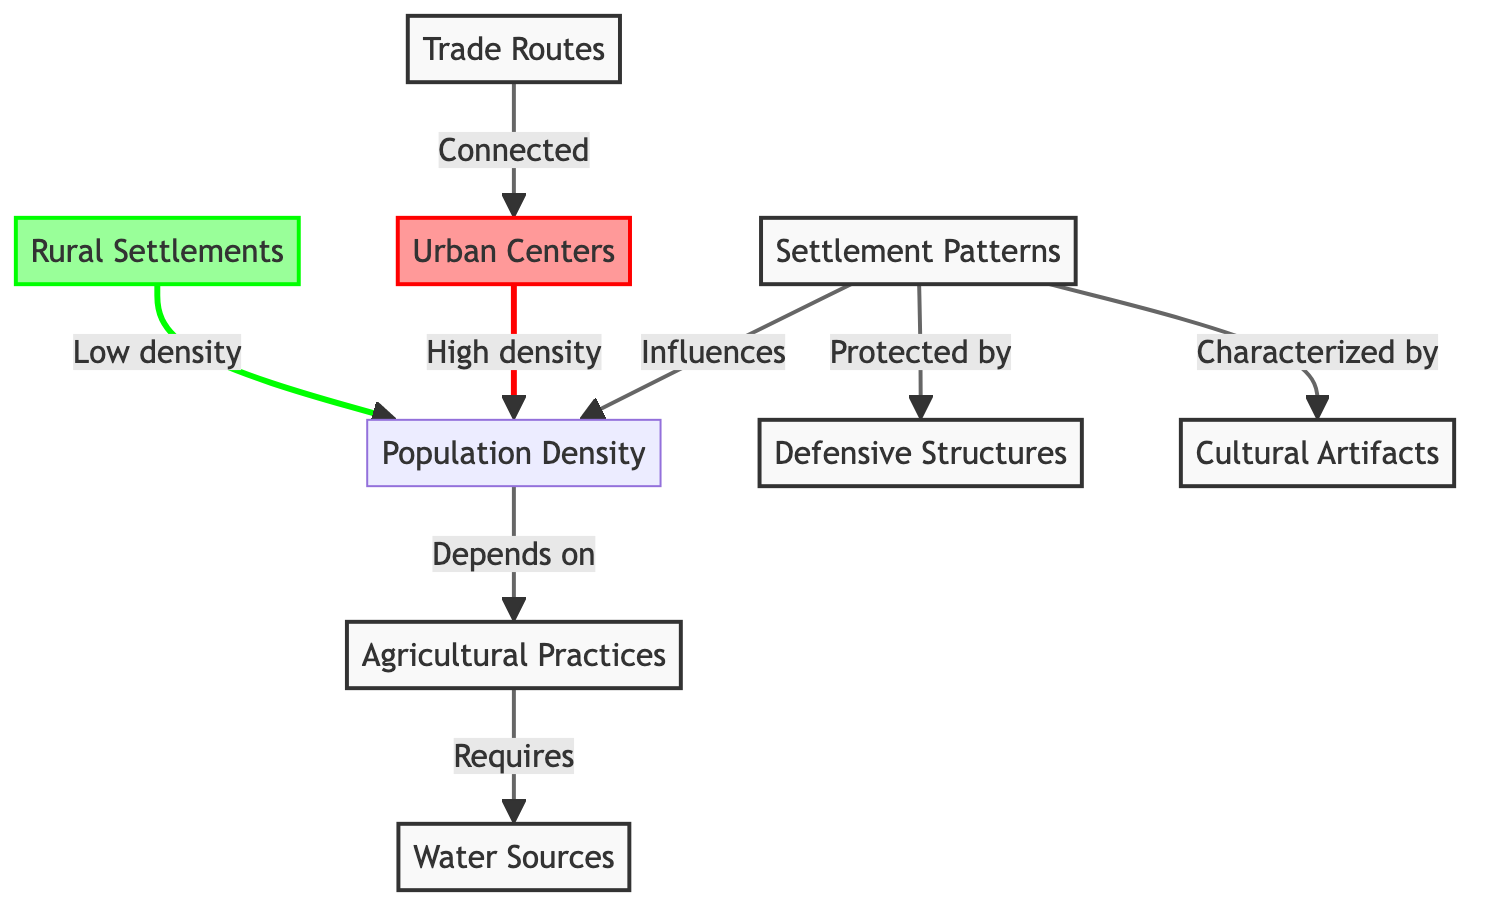What are the two main types of settlements depicted in the diagram? The diagram explicitly distinguishes between Urban Centers and Rural Settlements. These are categorized as the two primary types of settlements based on their population density and characteristics outlined in the visual structure.
Answer: Urban Centers, Rural Settlements Which node does Population Density depend on? According to the diagram, Population Density is shown to depend on Agricultural Practices. This connection is clearly indicated by the arrow from Agricultural Practices pointing toward Population Density, representing a direct link.
Answer: Agricultural Practices What influences Settlement Patterns? The diagram indicates that Settlement Patterns are influenced by Population Density. This relationship is clearly depicted by the arrow flowing from Population Density to Settlement Patterns, showing a dependency and influence.
Answer: Population Density How many nodes represent aspects of settlement? The diagram contains a total of seven nodes that can be categorized as aspects of settlement. These nodes include Settlement Patterns, Population Density, Agricultural Practices, Water Sources, Defensive Structures, Trade Routes, Urban Centers, and Rural Settlements. Counting all these nodes results in the total of seven.
Answer: 7 Which type of settlement is characterized by high population density? The diagram specifies that Urban Centers are characterized by high density. This is indicated by the distinct classification style associated with the Urban Centers node, which visually represents high density compared to its counterpart, Rural Settlements.
Answer: Urban Centers What requires Water Sources according to the diagram? According to the diagram, Agricultural Practices require Water Sources. This connection is established by the arrow leading from Water Sources directed towards Agricultural Practices, indicating that sufficient water supplies are essential for the success of agricultural methods.
Answer: Agricultural Practices Which two types of routes are connected according to the diagram? The diagram indicates that Trade Routes are connected to Urban Centers. This relationship is represented by the arrow leading from Trade Routes to Urban Centers, highlighting the interdependent nature of trade and urbanization within the context of ancient settlement patterns.
Answer: Trade Routes, Urban Centers What is the significance of Defensive Structures in relation to Settlement Patterns? The diagram illustrates that Defensive Structures are vital as they protect Settlement Patterns. This relationship is depicted by the arrow indicating a protective influence from Defensive Structures towards the broader concept of Settlement Patterns, illustrating the role of protection in settlement development.
Answer: Protects Settlement Patterns 